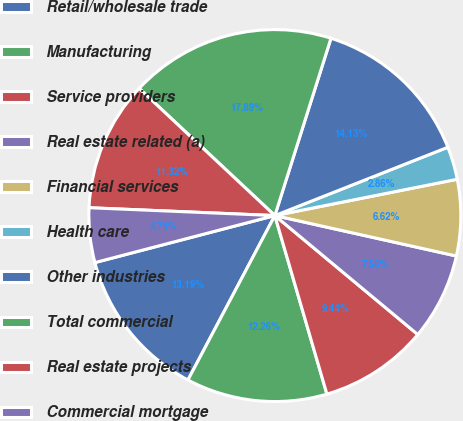<chart> <loc_0><loc_0><loc_500><loc_500><pie_chart><fcel>Retail/wholesale trade<fcel>Manufacturing<fcel>Service providers<fcel>Real estate related (a)<fcel>Financial services<fcel>Health care<fcel>Other industries<fcel>Total commercial<fcel>Real estate projects<fcel>Commercial mortgage<nl><fcel>13.2%<fcel>12.26%<fcel>9.44%<fcel>7.56%<fcel>6.62%<fcel>2.86%<fcel>14.14%<fcel>17.9%<fcel>11.32%<fcel>4.74%<nl></chart> 